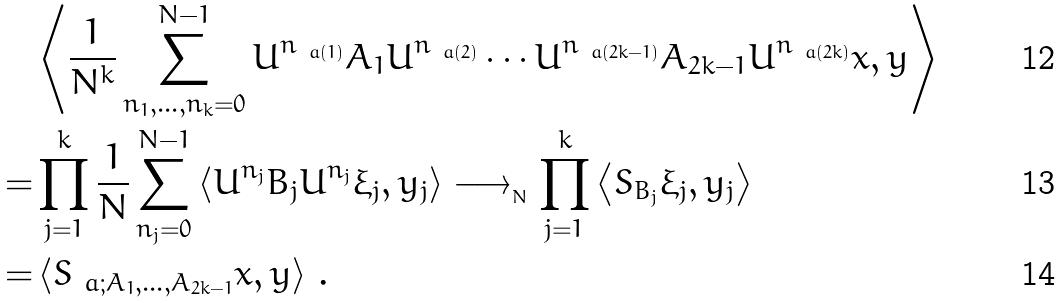Convert formula to latex. <formula><loc_0><loc_0><loc_500><loc_500>& \left \langle \frac { 1 } { N ^ { k } } \sum _ { n _ { 1 } , \dots , n _ { k } = 0 } ^ { N - 1 } U ^ { n _ { \ a ( 1 ) } } A _ { 1 } U ^ { n _ { \ a ( 2 ) } } \cdots U ^ { n _ { \ a ( 2 k - 1 ) } } A _ { 2 k - 1 } U ^ { n _ { \ a ( 2 k ) } } x , y \right \rangle \\ = & \prod _ { j = 1 } ^ { k } \frac { 1 } { N } \sum _ { n _ { j } = 0 } ^ { N - 1 } \left \langle U ^ { n _ { j } } B _ { j } U ^ { n _ { j } } \xi _ { j } , y _ { j } \right \rangle \longrightarrow _ { _ { N } } \prod _ { j = 1 } ^ { k } \left \langle S _ { B _ { j } } \xi _ { j } , y _ { j } \right \rangle \\ = & \left \langle S _ { \ a ; A _ { 1 } , \dots , A _ { 2 k - 1 } } x , y \right \rangle \, .</formula> 